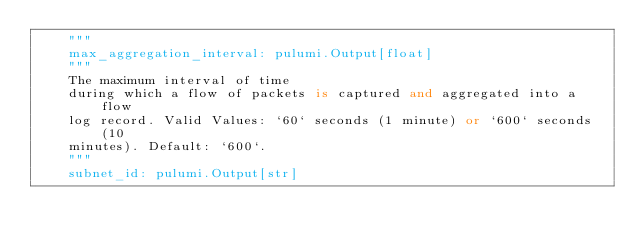Convert code to text. <code><loc_0><loc_0><loc_500><loc_500><_Python_>    """
    max_aggregation_interval: pulumi.Output[float]
    """
    The maximum interval of time
    during which a flow of packets is captured and aggregated into a flow
    log record. Valid Values: `60` seconds (1 minute) or `600` seconds (10
    minutes). Default: `600`.
    """
    subnet_id: pulumi.Output[str]</code> 